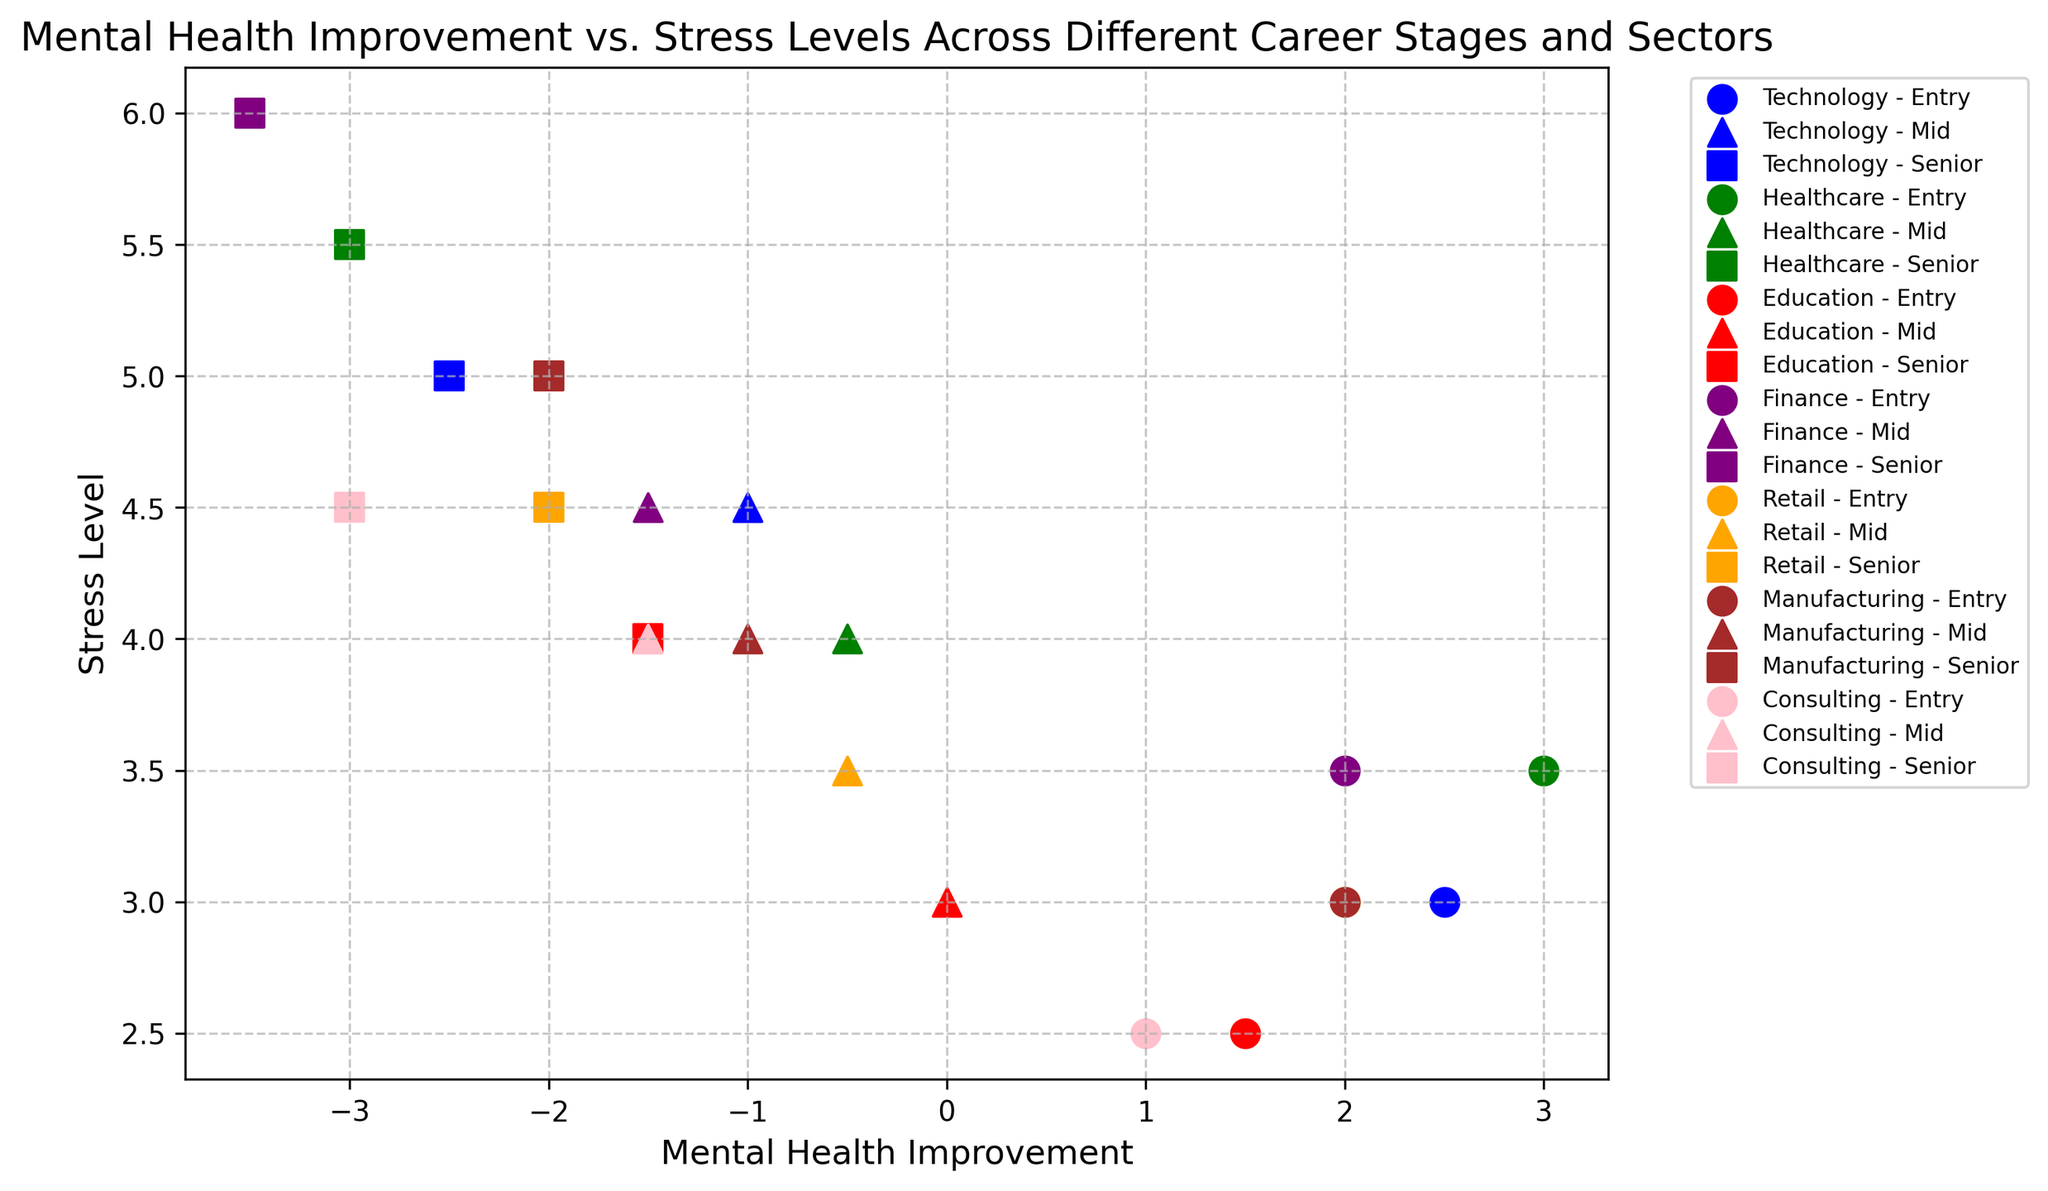What is the trend of mental health improvement from Entry to Senior levels in the Technology sector? From Entry to Mid to Senior levels in the Technology sector, mental health improvement drops: Entry (2.5), Mid (-1.0), Senior (-2.5).
Answer: Decreasing Which sector has the highest stress level at the Senior stage? Looking at the Senior stage data points, Finance has the highest stress level at 6.0.
Answer: Finance Compare the mental health improvement in the Entry stage across different sectors. Which sector shows the lowest improvement? Comparing Entry stage mental health improvement: Technology (2.5), Healthcare (3.0), Education (1.5), Finance (2.0), Retail (2.0), Manufacturing (2.0), Consulting (1.0). Consulting has the lowest improvement.
Answer: Consulting Identify the sector and career stage where mental health improvement is exactly zero. From the plot, Education at the Mid stage has a mental health improvement of zero.
Answer: Education - Mid Which sector shows the highest stress level in the Mid career stage? In the Mid stage, Finance shows the highest stress level with a level of 4.5.
Answer: Finance Compare mental health improvement between Entry and Mid stages in Retail. Which stage shows higher improvement? In Retail, Entry stage mental health improvement is 2.0, while Mid stage is -0.5, so Entry stage shows higher improvement.
Answer: Entry What is the difference in stress levels between Entry and Senior stages in Manufacturing? Stress level difference in Manufacturing: Entry (3.0) - Senior (5.0) = -2.0.
Answer: -2.0 In which career stage does Healthcare have the highest stress level, and what is the value? In Healthcare, the highest stress level is at the Senior stage with 5.5.
Answer: Senior, 5.5 Which sector's Mid stage has a mental health improvement closest to 0? Comparing Mid stage improvements: Technology (-1.0), Healthcare (-0.5), Education (0.0), Finance (-1.5), Retail (-0.5), Manufacturing (-1.0), Consulting (-1.5). Education has the improvement closest to 0.
Answer: Education Compare the stress levels across sectors in the Entry career stage. Which two sectors have the same stress level, and what is the value? Checking Entry stage stress levels: Technology (3.0), Healthcare (3.5), Education (2.5), Finance (3.5), Retail (3.0), Manufacturing (3.0), Consulting (2.5). Technology and Retail both have stress levels of 3.0.
Answer: Technology, Retail - 3.0 